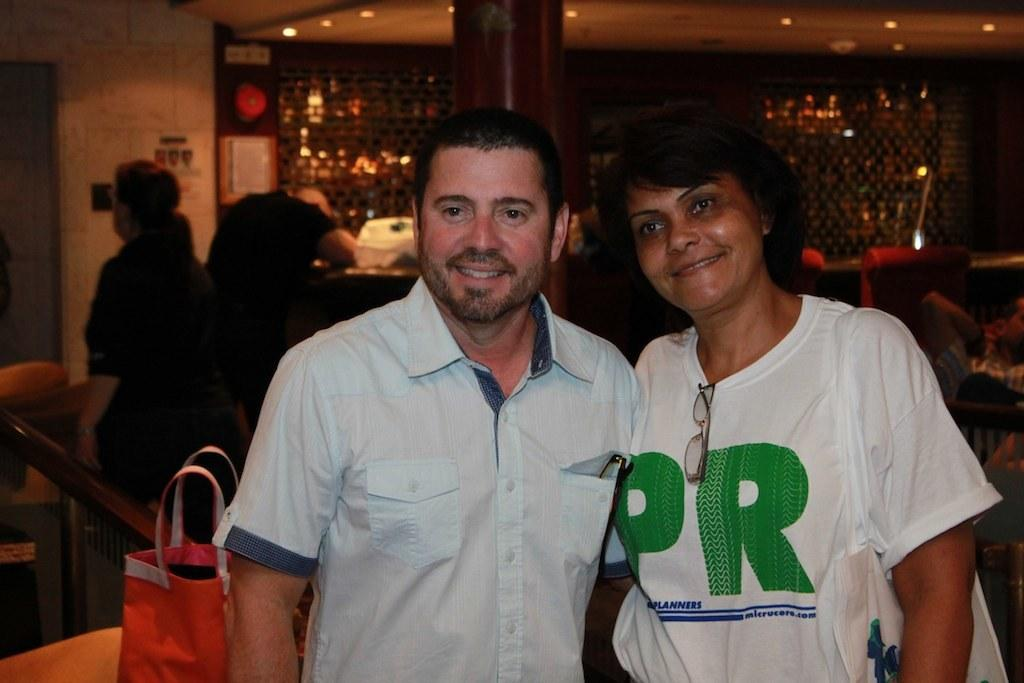How many people are present in the image? There are two people in the image. What is located on the left side of the image? There is a bag on the left side of the image. Can you describe the background of the image? There are people standing in the background of the image, and there are boards attached to the wall. What type of pocket can be seen on the person's clothing in the image? There is no pocket visible on the person's clothing in the image. What kind of error is being corrected on the boards in the background? There is no indication of an error being corrected on the boards in the background; they are simply attached to the wall. 